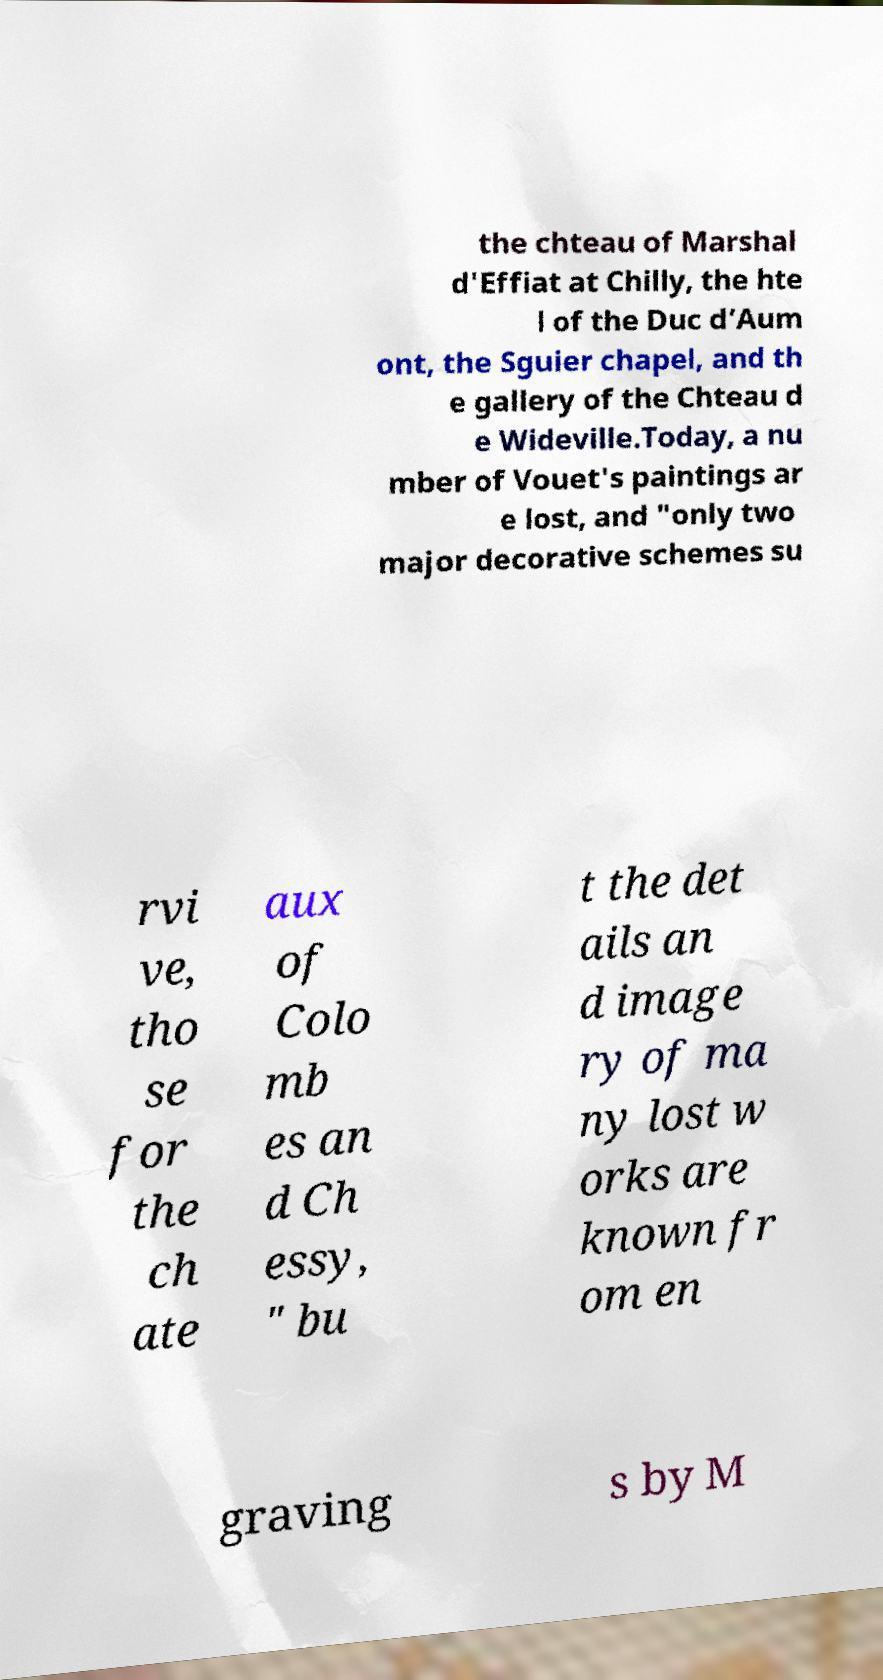What messages or text are displayed in this image? I need them in a readable, typed format. the chteau of Marshal d'Effiat at Chilly, the hte l of the Duc d’Aum ont, the Sguier chapel, and th e gallery of the Chteau d e Wideville.Today, a nu mber of Vouet's paintings ar e lost, and "only two major decorative schemes su rvi ve, tho se for the ch ate aux of Colo mb es an d Ch essy, " bu t the det ails an d image ry of ma ny lost w orks are known fr om en graving s by M 